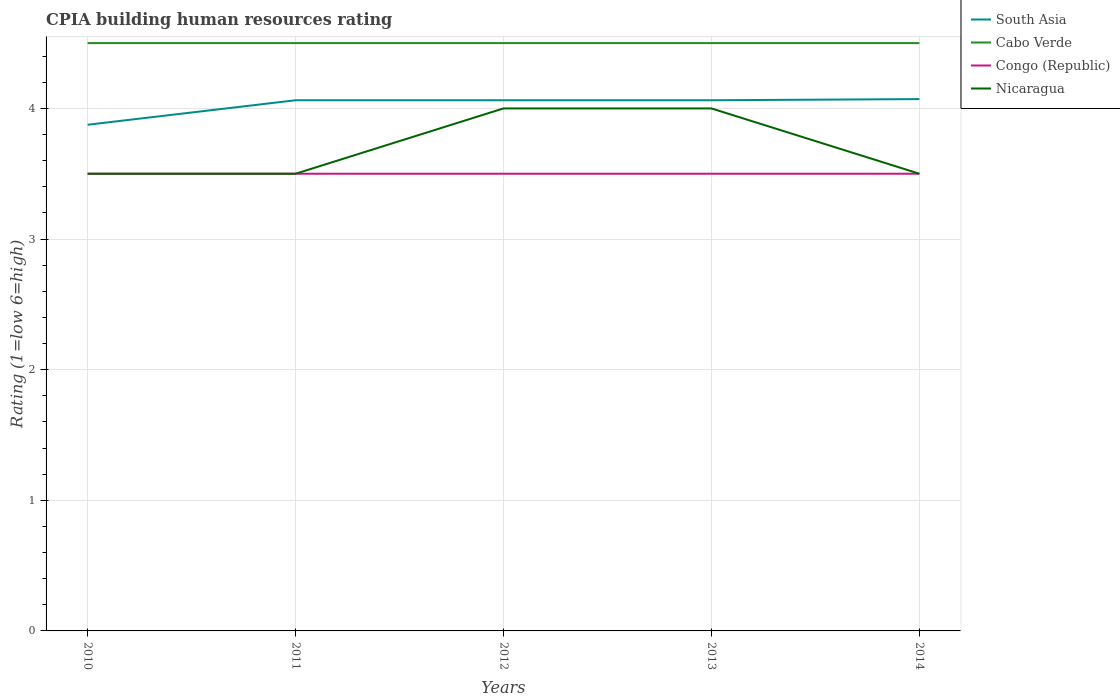Does the line corresponding to Congo (Republic) intersect with the line corresponding to Nicaragua?
Make the answer very short. Yes. Across all years, what is the maximum CPIA rating in South Asia?
Your response must be concise. 3.88. In which year was the CPIA rating in Nicaragua maximum?
Keep it short and to the point. 2010. What is the difference between the highest and the second highest CPIA rating in Nicaragua?
Your answer should be very brief. 0.5. What is the difference between two consecutive major ticks on the Y-axis?
Your answer should be very brief. 1. Are the values on the major ticks of Y-axis written in scientific E-notation?
Provide a short and direct response. No. How many legend labels are there?
Your response must be concise. 4. How are the legend labels stacked?
Your response must be concise. Vertical. What is the title of the graph?
Keep it short and to the point. CPIA building human resources rating. What is the label or title of the X-axis?
Your answer should be compact. Years. What is the label or title of the Y-axis?
Your answer should be very brief. Rating (1=low 6=high). What is the Rating (1=low 6=high) in South Asia in 2010?
Your answer should be very brief. 3.88. What is the Rating (1=low 6=high) in Cabo Verde in 2010?
Your answer should be compact. 4.5. What is the Rating (1=low 6=high) of Congo (Republic) in 2010?
Your response must be concise. 3.5. What is the Rating (1=low 6=high) in South Asia in 2011?
Offer a terse response. 4.06. What is the Rating (1=low 6=high) in Congo (Republic) in 2011?
Provide a short and direct response. 3.5. What is the Rating (1=low 6=high) of Nicaragua in 2011?
Provide a short and direct response. 3.5. What is the Rating (1=low 6=high) in South Asia in 2012?
Your answer should be very brief. 4.06. What is the Rating (1=low 6=high) of Cabo Verde in 2012?
Provide a succinct answer. 4.5. What is the Rating (1=low 6=high) in Nicaragua in 2012?
Offer a terse response. 4. What is the Rating (1=low 6=high) of South Asia in 2013?
Make the answer very short. 4.06. What is the Rating (1=low 6=high) of Congo (Republic) in 2013?
Your answer should be compact. 3.5. What is the Rating (1=low 6=high) of South Asia in 2014?
Keep it short and to the point. 4.07. What is the Rating (1=low 6=high) of Cabo Verde in 2014?
Keep it short and to the point. 4.5. What is the Rating (1=low 6=high) in Congo (Republic) in 2014?
Offer a very short reply. 3.5. Across all years, what is the maximum Rating (1=low 6=high) in South Asia?
Offer a very short reply. 4.07. Across all years, what is the minimum Rating (1=low 6=high) of South Asia?
Your answer should be compact. 3.88. What is the total Rating (1=low 6=high) in South Asia in the graph?
Your answer should be compact. 20.13. What is the difference between the Rating (1=low 6=high) in South Asia in 2010 and that in 2011?
Offer a terse response. -0.19. What is the difference between the Rating (1=low 6=high) of Cabo Verde in 2010 and that in 2011?
Keep it short and to the point. 0. What is the difference between the Rating (1=low 6=high) of South Asia in 2010 and that in 2012?
Your answer should be very brief. -0.19. What is the difference between the Rating (1=low 6=high) in Nicaragua in 2010 and that in 2012?
Your response must be concise. -0.5. What is the difference between the Rating (1=low 6=high) of South Asia in 2010 and that in 2013?
Offer a very short reply. -0.19. What is the difference between the Rating (1=low 6=high) in Cabo Verde in 2010 and that in 2013?
Offer a terse response. 0. What is the difference between the Rating (1=low 6=high) in Nicaragua in 2010 and that in 2013?
Ensure brevity in your answer.  -0.5. What is the difference between the Rating (1=low 6=high) in South Asia in 2010 and that in 2014?
Offer a very short reply. -0.2. What is the difference between the Rating (1=low 6=high) in Nicaragua in 2010 and that in 2014?
Keep it short and to the point. 0. What is the difference between the Rating (1=low 6=high) in South Asia in 2011 and that in 2012?
Offer a very short reply. 0. What is the difference between the Rating (1=low 6=high) of Cabo Verde in 2011 and that in 2012?
Keep it short and to the point. 0. What is the difference between the Rating (1=low 6=high) in Congo (Republic) in 2011 and that in 2012?
Ensure brevity in your answer.  0. What is the difference between the Rating (1=low 6=high) in Congo (Republic) in 2011 and that in 2013?
Provide a succinct answer. 0. What is the difference between the Rating (1=low 6=high) in South Asia in 2011 and that in 2014?
Provide a succinct answer. -0.01. What is the difference between the Rating (1=low 6=high) of Cabo Verde in 2011 and that in 2014?
Keep it short and to the point. 0. What is the difference between the Rating (1=low 6=high) of Nicaragua in 2011 and that in 2014?
Your answer should be compact. 0. What is the difference between the Rating (1=low 6=high) of South Asia in 2012 and that in 2013?
Offer a very short reply. 0. What is the difference between the Rating (1=low 6=high) of Cabo Verde in 2012 and that in 2013?
Provide a succinct answer. 0. What is the difference between the Rating (1=low 6=high) in Congo (Republic) in 2012 and that in 2013?
Offer a very short reply. 0. What is the difference between the Rating (1=low 6=high) in South Asia in 2012 and that in 2014?
Your response must be concise. -0.01. What is the difference between the Rating (1=low 6=high) in Cabo Verde in 2012 and that in 2014?
Offer a terse response. 0. What is the difference between the Rating (1=low 6=high) in Congo (Republic) in 2012 and that in 2014?
Give a very brief answer. 0. What is the difference between the Rating (1=low 6=high) in Nicaragua in 2012 and that in 2014?
Your answer should be very brief. 0.5. What is the difference between the Rating (1=low 6=high) of South Asia in 2013 and that in 2014?
Provide a short and direct response. -0.01. What is the difference between the Rating (1=low 6=high) of Congo (Republic) in 2013 and that in 2014?
Your response must be concise. 0. What is the difference between the Rating (1=low 6=high) of South Asia in 2010 and the Rating (1=low 6=high) of Cabo Verde in 2011?
Give a very brief answer. -0.62. What is the difference between the Rating (1=low 6=high) of South Asia in 2010 and the Rating (1=low 6=high) of Congo (Republic) in 2011?
Make the answer very short. 0.38. What is the difference between the Rating (1=low 6=high) in South Asia in 2010 and the Rating (1=low 6=high) in Nicaragua in 2011?
Give a very brief answer. 0.38. What is the difference between the Rating (1=low 6=high) of Cabo Verde in 2010 and the Rating (1=low 6=high) of Congo (Republic) in 2011?
Ensure brevity in your answer.  1. What is the difference between the Rating (1=low 6=high) of Congo (Republic) in 2010 and the Rating (1=low 6=high) of Nicaragua in 2011?
Your answer should be very brief. 0. What is the difference between the Rating (1=low 6=high) of South Asia in 2010 and the Rating (1=low 6=high) of Cabo Verde in 2012?
Provide a short and direct response. -0.62. What is the difference between the Rating (1=low 6=high) of South Asia in 2010 and the Rating (1=low 6=high) of Congo (Republic) in 2012?
Make the answer very short. 0.38. What is the difference between the Rating (1=low 6=high) in South Asia in 2010 and the Rating (1=low 6=high) in Nicaragua in 2012?
Your response must be concise. -0.12. What is the difference between the Rating (1=low 6=high) of Cabo Verde in 2010 and the Rating (1=low 6=high) of Congo (Republic) in 2012?
Give a very brief answer. 1. What is the difference between the Rating (1=low 6=high) in South Asia in 2010 and the Rating (1=low 6=high) in Cabo Verde in 2013?
Offer a terse response. -0.62. What is the difference between the Rating (1=low 6=high) in South Asia in 2010 and the Rating (1=low 6=high) in Nicaragua in 2013?
Offer a terse response. -0.12. What is the difference between the Rating (1=low 6=high) in Cabo Verde in 2010 and the Rating (1=low 6=high) in Congo (Republic) in 2013?
Give a very brief answer. 1. What is the difference between the Rating (1=low 6=high) in Cabo Verde in 2010 and the Rating (1=low 6=high) in Nicaragua in 2013?
Give a very brief answer. 0.5. What is the difference between the Rating (1=low 6=high) of Congo (Republic) in 2010 and the Rating (1=low 6=high) of Nicaragua in 2013?
Your response must be concise. -0.5. What is the difference between the Rating (1=low 6=high) in South Asia in 2010 and the Rating (1=low 6=high) in Cabo Verde in 2014?
Your answer should be compact. -0.62. What is the difference between the Rating (1=low 6=high) in Cabo Verde in 2010 and the Rating (1=low 6=high) in Nicaragua in 2014?
Make the answer very short. 1. What is the difference between the Rating (1=low 6=high) in Congo (Republic) in 2010 and the Rating (1=low 6=high) in Nicaragua in 2014?
Provide a short and direct response. 0. What is the difference between the Rating (1=low 6=high) of South Asia in 2011 and the Rating (1=low 6=high) of Cabo Verde in 2012?
Your answer should be very brief. -0.44. What is the difference between the Rating (1=low 6=high) in South Asia in 2011 and the Rating (1=low 6=high) in Congo (Republic) in 2012?
Offer a terse response. 0.56. What is the difference between the Rating (1=low 6=high) in South Asia in 2011 and the Rating (1=low 6=high) in Nicaragua in 2012?
Your response must be concise. 0.06. What is the difference between the Rating (1=low 6=high) of Cabo Verde in 2011 and the Rating (1=low 6=high) of Nicaragua in 2012?
Your answer should be very brief. 0.5. What is the difference between the Rating (1=low 6=high) in Congo (Republic) in 2011 and the Rating (1=low 6=high) in Nicaragua in 2012?
Provide a short and direct response. -0.5. What is the difference between the Rating (1=low 6=high) of South Asia in 2011 and the Rating (1=low 6=high) of Cabo Verde in 2013?
Your answer should be very brief. -0.44. What is the difference between the Rating (1=low 6=high) in South Asia in 2011 and the Rating (1=low 6=high) in Congo (Republic) in 2013?
Offer a terse response. 0.56. What is the difference between the Rating (1=low 6=high) in South Asia in 2011 and the Rating (1=low 6=high) in Nicaragua in 2013?
Your answer should be very brief. 0.06. What is the difference between the Rating (1=low 6=high) in South Asia in 2011 and the Rating (1=low 6=high) in Cabo Verde in 2014?
Provide a short and direct response. -0.44. What is the difference between the Rating (1=low 6=high) of South Asia in 2011 and the Rating (1=low 6=high) of Congo (Republic) in 2014?
Ensure brevity in your answer.  0.56. What is the difference between the Rating (1=low 6=high) in South Asia in 2011 and the Rating (1=low 6=high) in Nicaragua in 2014?
Your response must be concise. 0.56. What is the difference between the Rating (1=low 6=high) in Cabo Verde in 2011 and the Rating (1=low 6=high) in Congo (Republic) in 2014?
Offer a very short reply. 1. What is the difference between the Rating (1=low 6=high) of Cabo Verde in 2011 and the Rating (1=low 6=high) of Nicaragua in 2014?
Keep it short and to the point. 1. What is the difference between the Rating (1=low 6=high) of South Asia in 2012 and the Rating (1=low 6=high) of Cabo Verde in 2013?
Your response must be concise. -0.44. What is the difference between the Rating (1=low 6=high) of South Asia in 2012 and the Rating (1=low 6=high) of Congo (Republic) in 2013?
Offer a very short reply. 0.56. What is the difference between the Rating (1=low 6=high) of South Asia in 2012 and the Rating (1=low 6=high) of Nicaragua in 2013?
Provide a succinct answer. 0.06. What is the difference between the Rating (1=low 6=high) in Cabo Verde in 2012 and the Rating (1=low 6=high) in Congo (Republic) in 2013?
Provide a short and direct response. 1. What is the difference between the Rating (1=low 6=high) in Cabo Verde in 2012 and the Rating (1=low 6=high) in Nicaragua in 2013?
Offer a very short reply. 0.5. What is the difference between the Rating (1=low 6=high) in Congo (Republic) in 2012 and the Rating (1=low 6=high) in Nicaragua in 2013?
Your response must be concise. -0.5. What is the difference between the Rating (1=low 6=high) in South Asia in 2012 and the Rating (1=low 6=high) in Cabo Verde in 2014?
Your answer should be very brief. -0.44. What is the difference between the Rating (1=low 6=high) in South Asia in 2012 and the Rating (1=low 6=high) in Congo (Republic) in 2014?
Keep it short and to the point. 0.56. What is the difference between the Rating (1=low 6=high) of South Asia in 2012 and the Rating (1=low 6=high) of Nicaragua in 2014?
Ensure brevity in your answer.  0.56. What is the difference between the Rating (1=low 6=high) of Cabo Verde in 2012 and the Rating (1=low 6=high) of Nicaragua in 2014?
Your answer should be very brief. 1. What is the difference between the Rating (1=low 6=high) of South Asia in 2013 and the Rating (1=low 6=high) of Cabo Verde in 2014?
Offer a very short reply. -0.44. What is the difference between the Rating (1=low 6=high) of South Asia in 2013 and the Rating (1=low 6=high) of Congo (Republic) in 2014?
Provide a short and direct response. 0.56. What is the difference between the Rating (1=low 6=high) in South Asia in 2013 and the Rating (1=low 6=high) in Nicaragua in 2014?
Make the answer very short. 0.56. What is the difference between the Rating (1=low 6=high) of Cabo Verde in 2013 and the Rating (1=low 6=high) of Nicaragua in 2014?
Your response must be concise. 1. What is the average Rating (1=low 6=high) of South Asia per year?
Your answer should be very brief. 4.03. What is the average Rating (1=low 6=high) in Cabo Verde per year?
Your answer should be very brief. 4.5. In the year 2010, what is the difference between the Rating (1=low 6=high) in South Asia and Rating (1=low 6=high) in Cabo Verde?
Offer a terse response. -0.62. In the year 2010, what is the difference between the Rating (1=low 6=high) in South Asia and Rating (1=low 6=high) in Nicaragua?
Give a very brief answer. 0.38. In the year 2010, what is the difference between the Rating (1=low 6=high) in Cabo Verde and Rating (1=low 6=high) in Congo (Republic)?
Make the answer very short. 1. In the year 2011, what is the difference between the Rating (1=low 6=high) in South Asia and Rating (1=low 6=high) in Cabo Verde?
Offer a terse response. -0.44. In the year 2011, what is the difference between the Rating (1=low 6=high) in South Asia and Rating (1=low 6=high) in Congo (Republic)?
Your response must be concise. 0.56. In the year 2011, what is the difference between the Rating (1=low 6=high) of South Asia and Rating (1=low 6=high) of Nicaragua?
Keep it short and to the point. 0.56. In the year 2012, what is the difference between the Rating (1=low 6=high) of South Asia and Rating (1=low 6=high) of Cabo Verde?
Give a very brief answer. -0.44. In the year 2012, what is the difference between the Rating (1=low 6=high) in South Asia and Rating (1=low 6=high) in Congo (Republic)?
Provide a short and direct response. 0.56. In the year 2012, what is the difference between the Rating (1=low 6=high) in South Asia and Rating (1=low 6=high) in Nicaragua?
Give a very brief answer. 0.06. In the year 2013, what is the difference between the Rating (1=low 6=high) in South Asia and Rating (1=low 6=high) in Cabo Verde?
Make the answer very short. -0.44. In the year 2013, what is the difference between the Rating (1=low 6=high) of South Asia and Rating (1=low 6=high) of Congo (Republic)?
Keep it short and to the point. 0.56. In the year 2013, what is the difference between the Rating (1=low 6=high) of South Asia and Rating (1=low 6=high) of Nicaragua?
Your answer should be very brief. 0.06. In the year 2013, what is the difference between the Rating (1=low 6=high) of Cabo Verde and Rating (1=low 6=high) of Congo (Republic)?
Provide a succinct answer. 1. In the year 2013, what is the difference between the Rating (1=low 6=high) in Cabo Verde and Rating (1=low 6=high) in Nicaragua?
Your response must be concise. 0.5. In the year 2013, what is the difference between the Rating (1=low 6=high) in Congo (Republic) and Rating (1=low 6=high) in Nicaragua?
Offer a very short reply. -0.5. In the year 2014, what is the difference between the Rating (1=low 6=high) in South Asia and Rating (1=low 6=high) in Cabo Verde?
Provide a succinct answer. -0.43. In the year 2014, what is the difference between the Rating (1=low 6=high) in South Asia and Rating (1=low 6=high) in Nicaragua?
Your response must be concise. 0.57. In the year 2014, what is the difference between the Rating (1=low 6=high) in Cabo Verde and Rating (1=low 6=high) in Congo (Republic)?
Offer a very short reply. 1. In the year 2014, what is the difference between the Rating (1=low 6=high) of Cabo Verde and Rating (1=low 6=high) of Nicaragua?
Your answer should be compact. 1. In the year 2014, what is the difference between the Rating (1=low 6=high) in Congo (Republic) and Rating (1=low 6=high) in Nicaragua?
Offer a terse response. 0. What is the ratio of the Rating (1=low 6=high) of South Asia in 2010 to that in 2011?
Give a very brief answer. 0.95. What is the ratio of the Rating (1=low 6=high) of Cabo Verde in 2010 to that in 2011?
Make the answer very short. 1. What is the ratio of the Rating (1=low 6=high) of Congo (Republic) in 2010 to that in 2011?
Ensure brevity in your answer.  1. What is the ratio of the Rating (1=low 6=high) in South Asia in 2010 to that in 2012?
Provide a succinct answer. 0.95. What is the ratio of the Rating (1=low 6=high) of Cabo Verde in 2010 to that in 2012?
Ensure brevity in your answer.  1. What is the ratio of the Rating (1=low 6=high) of Congo (Republic) in 2010 to that in 2012?
Your answer should be very brief. 1. What is the ratio of the Rating (1=low 6=high) in Nicaragua in 2010 to that in 2012?
Offer a very short reply. 0.88. What is the ratio of the Rating (1=low 6=high) in South Asia in 2010 to that in 2013?
Provide a succinct answer. 0.95. What is the ratio of the Rating (1=low 6=high) in Congo (Republic) in 2010 to that in 2013?
Give a very brief answer. 1. What is the ratio of the Rating (1=low 6=high) of South Asia in 2010 to that in 2014?
Keep it short and to the point. 0.95. What is the ratio of the Rating (1=low 6=high) in Cabo Verde in 2010 to that in 2014?
Ensure brevity in your answer.  1. What is the ratio of the Rating (1=low 6=high) in Cabo Verde in 2011 to that in 2012?
Provide a succinct answer. 1. What is the ratio of the Rating (1=low 6=high) of Congo (Republic) in 2011 to that in 2012?
Your response must be concise. 1. What is the ratio of the Rating (1=low 6=high) of Nicaragua in 2011 to that in 2012?
Keep it short and to the point. 0.88. What is the ratio of the Rating (1=low 6=high) of South Asia in 2011 to that in 2013?
Offer a very short reply. 1. What is the ratio of the Rating (1=low 6=high) of Congo (Republic) in 2011 to that in 2013?
Your answer should be compact. 1. What is the ratio of the Rating (1=low 6=high) of Congo (Republic) in 2011 to that in 2014?
Offer a very short reply. 1. What is the ratio of the Rating (1=low 6=high) in South Asia in 2012 to that in 2013?
Give a very brief answer. 1. What is the ratio of the Rating (1=low 6=high) in Cabo Verde in 2012 to that in 2013?
Provide a succinct answer. 1. What is the ratio of the Rating (1=low 6=high) of Congo (Republic) in 2012 to that in 2013?
Your answer should be very brief. 1. What is the ratio of the Rating (1=low 6=high) in South Asia in 2013 to that in 2014?
Provide a succinct answer. 1. What is the ratio of the Rating (1=low 6=high) in Cabo Verde in 2013 to that in 2014?
Offer a very short reply. 1. What is the ratio of the Rating (1=low 6=high) in Nicaragua in 2013 to that in 2014?
Offer a very short reply. 1.14. What is the difference between the highest and the second highest Rating (1=low 6=high) in South Asia?
Make the answer very short. 0.01. What is the difference between the highest and the second highest Rating (1=low 6=high) in Congo (Republic)?
Give a very brief answer. 0. What is the difference between the highest and the second highest Rating (1=low 6=high) of Nicaragua?
Offer a very short reply. 0. What is the difference between the highest and the lowest Rating (1=low 6=high) in South Asia?
Keep it short and to the point. 0.2. What is the difference between the highest and the lowest Rating (1=low 6=high) of Cabo Verde?
Ensure brevity in your answer.  0. 